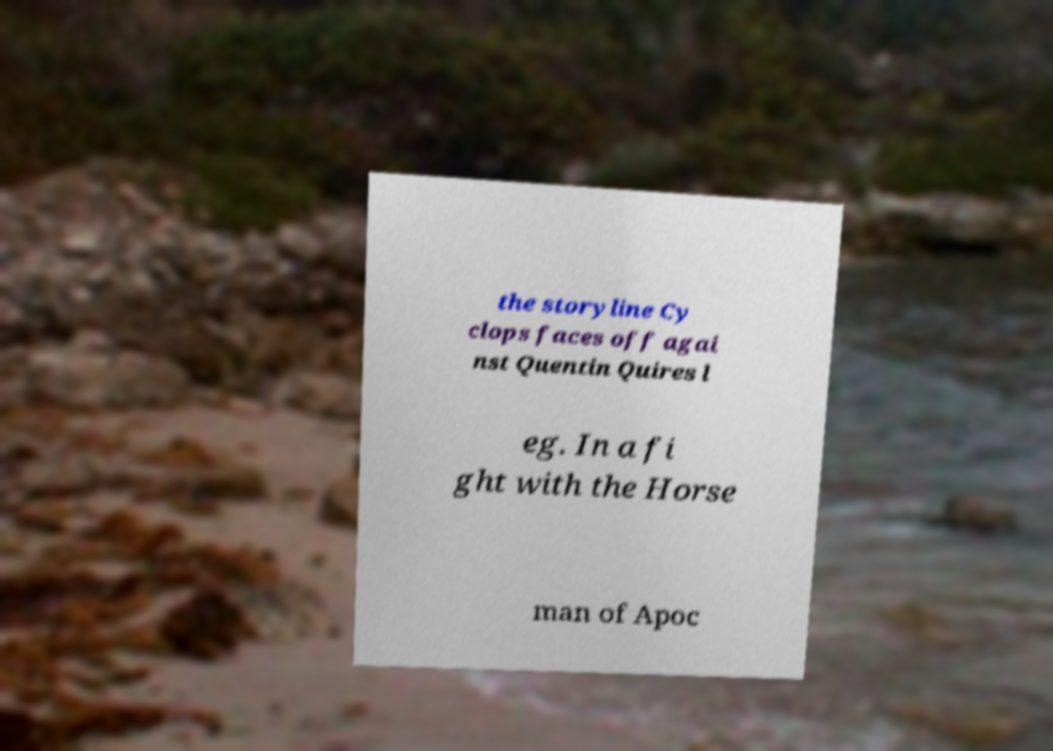Can you read and provide the text displayed in the image?This photo seems to have some interesting text. Can you extract and type it out for me? the storyline Cy clops faces off agai nst Quentin Quires l eg. In a fi ght with the Horse man of Apoc 